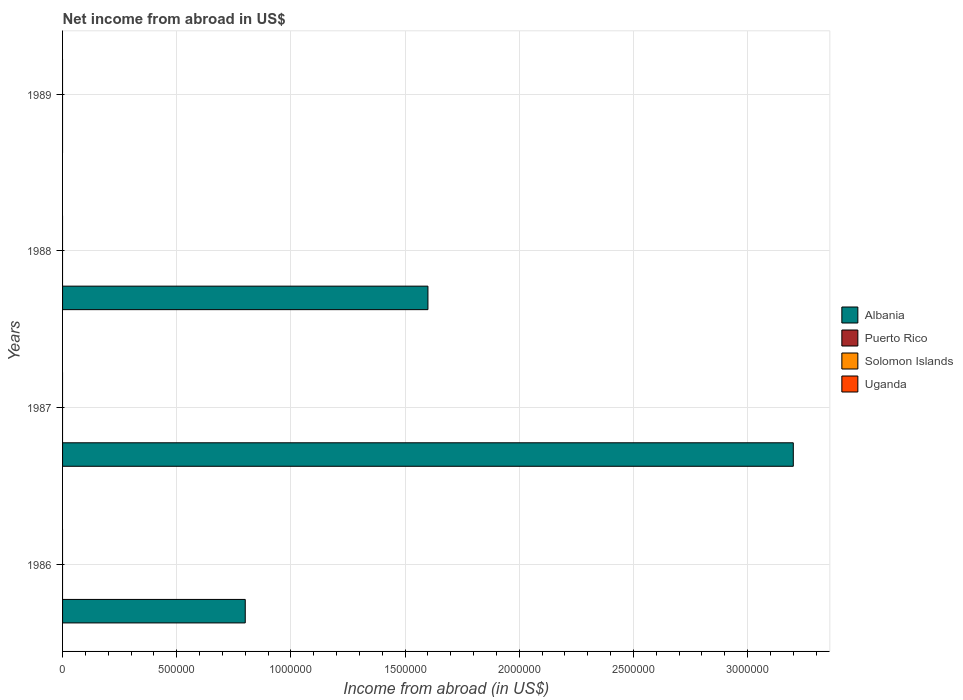How many different coloured bars are there?
Make the answer very short. 1. Are the number of bars on each tick of the Y-axis equal?
Give a very brief answer. No. In how many cases, is the number of bars for a given year not equal to the number of legend labels?
Provide a short and direct response. 4. Across all years, what is the maximum net income from abroad in Albania?
Your answer should be compact. 3.20e+06. In which year was the net income from abroad in Albania maximum?
Your answer should be compact. 1987. What is the total net income from abroad in Albania in the graph?
Provide a succinct answer. 5.60e+06. What is the difference between the net income from abroad in Albania in 1986 and that in 1988?
Give a very brief answer. -8.00e+05. What is the difference between the highest and the second highest net income from abroad in Albania?
Make the answer very short. 1.60e+06. In how many years, is the net income from abroad in Solomon Islands greater than the average net income from abroad in Solomon Islands taken over all years?
Offer a very short reply. 0. Is it the case that in every year, the sum of the net income from abroad in Albania and net income from abroad in Puerto Rico is greater than the sum of net income from abroad in Uganda and net income from abroad in Solomon Islands?
Keep it short and to the point. No. How many bars are there?
Give a very brief answer. 3. Does the graph contain any zero values?
Provide a succinct answer. Yes. Does the graph contain grids?
Keep it short and to the point. Yes. How many legend labels are there?
Your answer should be very brief. 4. How are the legend labels stacked?
Offer a very short reply. Vertical. What is the title of the graph?
Your answer should be compact. Net income from abroad in US$. What is the label or title of the X-axis?
Make the answer very short. Income from abroad (in US$). What is the Income from abroad (in US$) in Solomon Islands in 1986?
Your response must be concise. 0. What is the Income from abroad (in US$) of Uganda in 1986?
Make the answer very short. 0. What is the Income from abroad (in US$) in Albania in 1987?
Keep it short and to the point. 3.20e+06. What is the Income from abroad (in US$) in Puerto Rico in 1987?
Offer a terse response. 0. What is the Income from abroad (in US$) in Solomon Islands in 1987?
Offer a very short reply. 0. What is the Income from abroad (in US$) in Uganda in 1987?
Offer a very short reply. 0. What is the Income from abroad (in US$) of Albania in 1988?
Your answer should be very brief. 1.60e+06. What is the Income from abroad (in US$) in Puerto Rico in 1988?
Make the answer very short. 0. What is the Income from abroad (in US$) in Solomon Islands in 1988?
Provide a short and direct response. 0. What is the Income from abroad (in US$) in Albania in 1989?
Your answer should be compact. 0. What is the Income from abroad (in US$) in Solomon Islands in 1989?
Provide a succinct answer. 0. Across all years, what is the maximum Income from abroad (in US$) in Albania?
Keep it short and to the point. 3.20e+06. What is the total Income from abroad (in US$) of Albania in the graph?
Offer a terse response. 5.60e+06. What is the total Income from abroad (in US$) of Puerto Rico in the graph?
Offer a very short reply. 0. What is the total Income from abroad (in US$) in Solomon Islands in the graph?
Offer a very short reply. 0. What is the difference between the Income from abroad (in US$) of Albania in 1986 and that in 1987?
Give a very brief answer. -2.40e+06. What is the difference between the Income from abroad (in US$) of Albania in 1986 and that in 1988?
Your response must be concise. -8.00e+05. What is the difference between the Income from abroad (in US$) of Albania in 1987 and that in 1988?
Your response must be concise. 1.60e+06. What is the average Income from abroad (in US$) in Albania per year?
Your answer should be compact. 1.40e+06. What is the average Income from abroad (in US$) of Puerto Rico per year?
Ensure brevity in your answer.  0. What is the average Income from abroad (in US$) of Uganda per year?
Your answer should be compact. 0. What is the ratio of the Income from abroad (in US$) of Albania in 1987 to that in 1988?
Your answer should be compact. 2. What is the difference between the highest and the second highest Income from abroad (in US$) in Albania?
Your answer should be very brief. 1.60e+06. What is the difference between the highest and the lowest Income from abroad (in US$) of Albania?
Offer a terse response. 3.20e+06. 